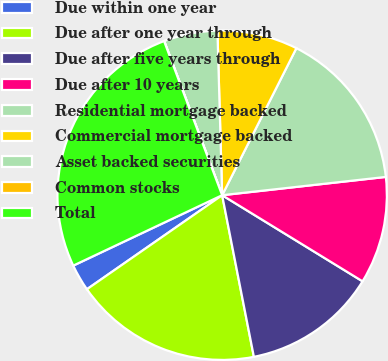<chart> <loc_0><loc_0><loc_500><loc_500><pie_chart><fcel>Due within one year<fcel>Due after one year through<fcel>Due after five years through<fcel>Due after 10 years<fcel>Residential mortgage backed<fcel>Commercial mortgage backed<fcel>Asset backed securities<fcel>Common stocks<fcel>Total<nl><fcel>2.64%<fcel>18.42%<fcel>13.16%<fcel>10.53%<fcel>15.79%<fcel>7.9%<fcel>5.27%<fcel>0.01%<fcel>26.3%<nl></chart> 